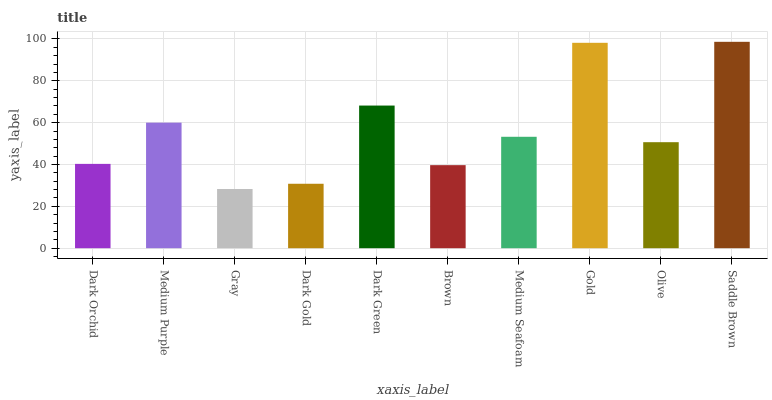Is Gray the minimum?
Answer yes or no. Yes. Is Saddle Brown the maximum?
Answer yes or no. Yes. Is Medium Purple the minimum?
Answer yes or no. No. Is Medium Purple the maximum?
Answer yes or no. No. Is Medium Purple greater than Dark Orchid?
Answer yes or no. Yes. Is Dark Orchid less than Medium Purple?
Answer yes or no. Yes. Is Dark Orchid greater than Medium Purple?
Answer yes or no. No. Is Medium Purple less than Dark Orchid?
Answer yes or no. No. Is Medium Seafoam the high median?
Answer yes or no. Yes. Is Olive the low median?
Answer yes or no. Yes. Is Medium Purple the high median?
Answer yes or no. No. Is Dark Orchid the low median?
Answer yes or no. No. 